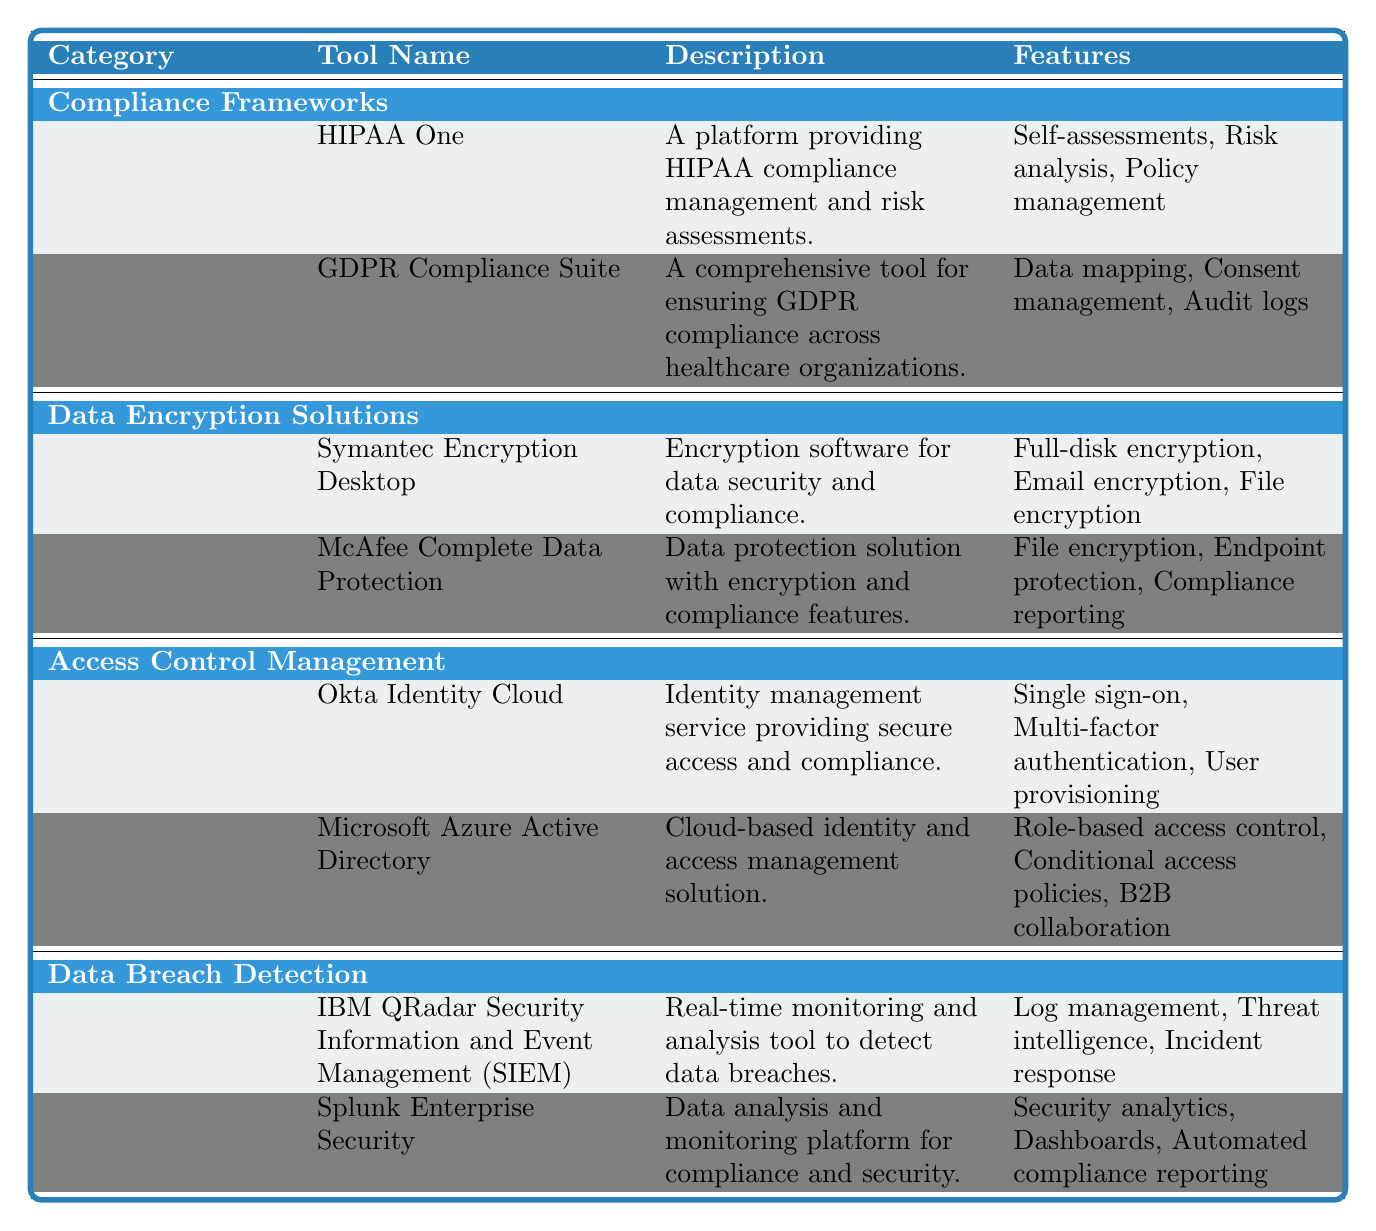What tools fall under the category of Compliance Frameworks? By referring to the table, we can identify the category of Compliance Frameworks and list the tools that fall under it. In the Compliance Frameworks section, there are two tools: HIPAA One and GDPR Compliance Suite.
Answer: HIPAA One, GDPR Compliance Suite Which organization provides the GDPR Compliance Suite? The organization can be found in the corresponding row for the GDPR Compliance Suite in the table under the Organization column. It states that the GDPR Compliance Suite is provided by ComplianceQuest.
Answer: ComplianceQuest Are there any tools in the Data Encryption Solutions category that offer full-disk encryption? We need to check the tools listed in the Data Encryption Solutions category and review their features. The tool Symantec Encryption Desktop specifically mentions full-disk encryption as a feature.
Answer: Yes How many features does Okta Identity Cloud offer? From the table, we can see the features listed under the description for Okta Identity Cloud. It contains three features: Single sign-on, Multi-factor authentication, and User provisioning. Therefore, we count the number of features listed.
Answer: 3 Which tool has the feature of compliance reporting? We look through the features of all tools to find one that includes compliance reporting. The tool McAfee Complete Data Protection has compliance reporting as one of its listed features.
Answer: McAfee Complete Data Protection What is the primary function of the IBM QRadar Security Information and Event Management tool? This can be determined by reading the description provided for the IBM QRadar SIEM in the table. The description states that it is a real-time monitoring and analysis tool to detect data breaches.
Answer: Real-time monitoring and analysis tool for data breaches Which category includes both tools that offer risk analysis and audit logs? First, look for the tools that offer risk analysis and audit logs in the table. Risk analysis is a feature of HIPAA One, and audit logs are a feature of GDPR Compliance Suite, both of which are in the Compliance Frameworks category. Therefore, the answer is Compliance Frameworks.
Answer: Compliance Frameworks What organization provides tools for Access Control Management? The table indicates that two tools are listed under the Access Control Management category. We identify the organizations associated with these tools: Okta Identity Cloud is provided by Okta Inc., and Microsoft Azure Active Directory is provided by Microsoft. Since there are two organizations, we state both.
Answer: Okta Inc., Microsoft 